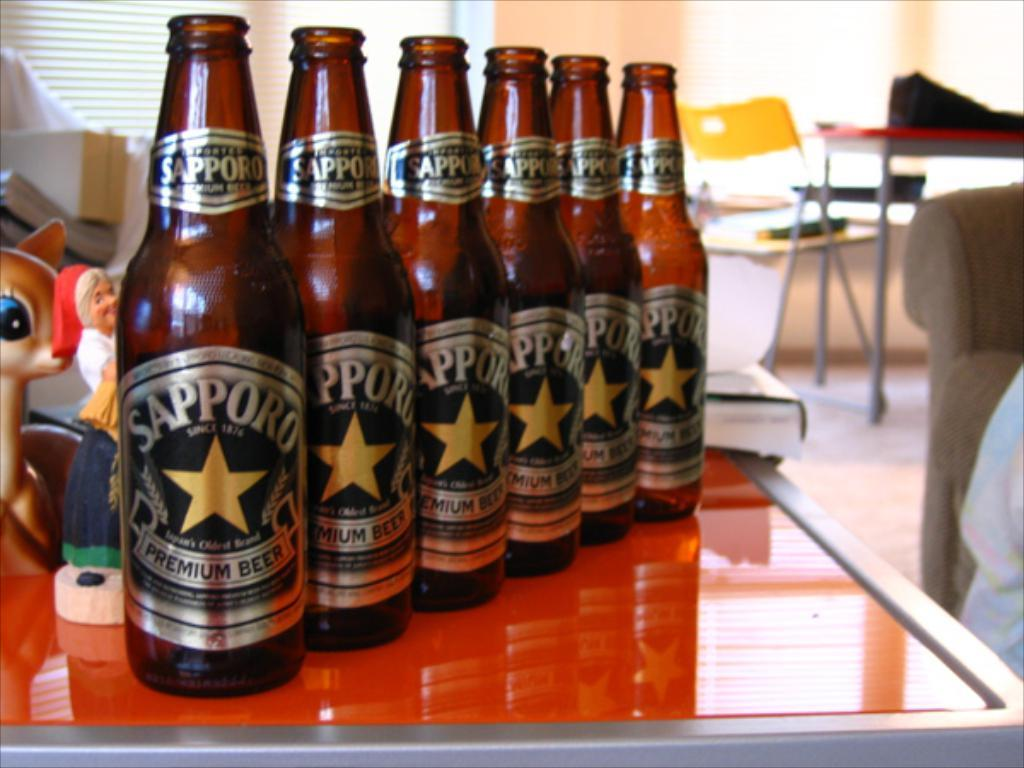<image>
Present a compact description of the photo's key features. Six bottles of Sapporo beer lie on a table. 